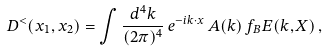<formula> <loc_0><loc_0><loc_500><loc_500>D ^ { < } ( x _ { 1 } , x _ { 2 } ) = \int \frac { d ^ { 4 } k } { ( 2 \pi ) ^ { 4 } } \, e ^ { - i k \cdot x } \, A ( k ) \, f _ { B } E ( k , X ) \, ,</formula> 